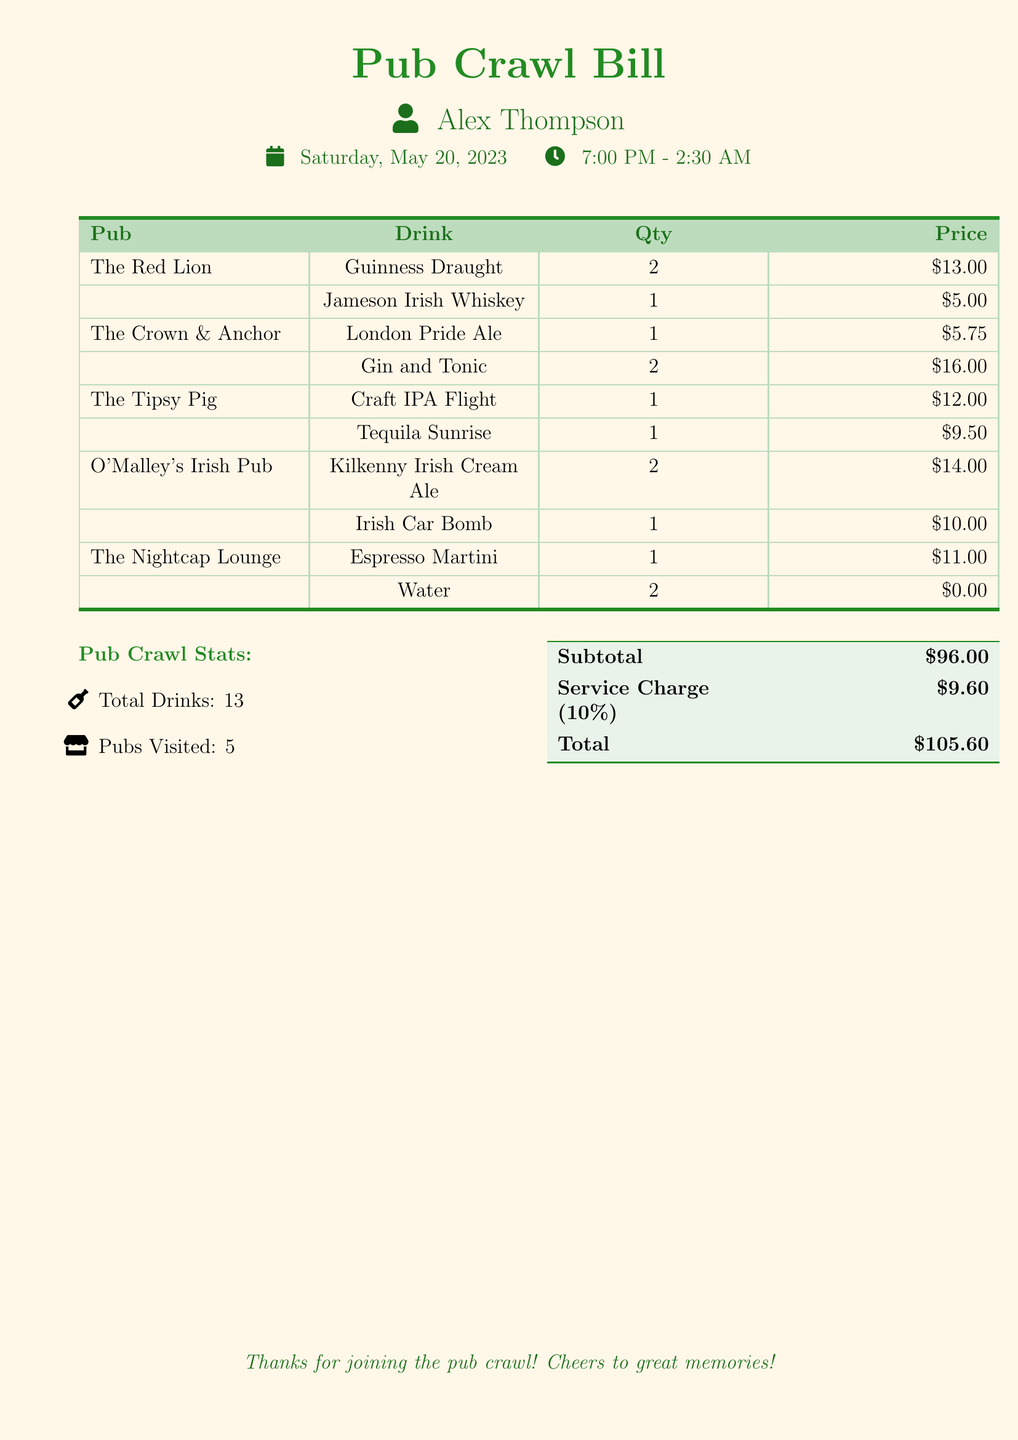What is the name of the person on the bill? The document lists the name of the person at the top, which is Alex Thompson.
Answer: Alex Thompson What drink had the highest price? To find the drink with the highest price, we examine the prices listed. The Tequila Sunrise is priced at $9.50, which is among the higher prices, but the Espresso Martini is $11.00, making it the highest.
Answer: Espresso Martini How many pubs were visited? The document specifies the number of pubs in the stats section, stating there were 5 pubs visited.
Answer: 5 What is the total cost of the drinks consumed? Total cost is indicated in the final calculations of the document, where it states the total is $105.60.
Answer: $105.60 How many drinks were Irish Whiskeys ordered? The drinks section shows that only one Irish Whiskey was ordered, which is the Jameson Irish Whiskey.
Answer: 1 What is the subtotal before the service charge? The subtotal is explicitly listed in the document before the service charge is added, indicating a subtotal of $96.00.
Answer: $96.00 What was the date of the pub crawl? The date is provided right under the person’s name and is clearly stated as Saturday, May 20, 2023.
Answer: Saturday, May 20, 2023 What type of drink was ordered twice at O'Malley's Irish Pub? The document specifies that Kilkenny Irish Cream Ale was ordered twice at O'Malley's Irish Pub.
Answer: Kilkenny Irish Cream Ale How many water drinks were included in the tab? The drink table indicates that 2 waters were ordered, which is listed with a $0.00 price.
Answer: 2 